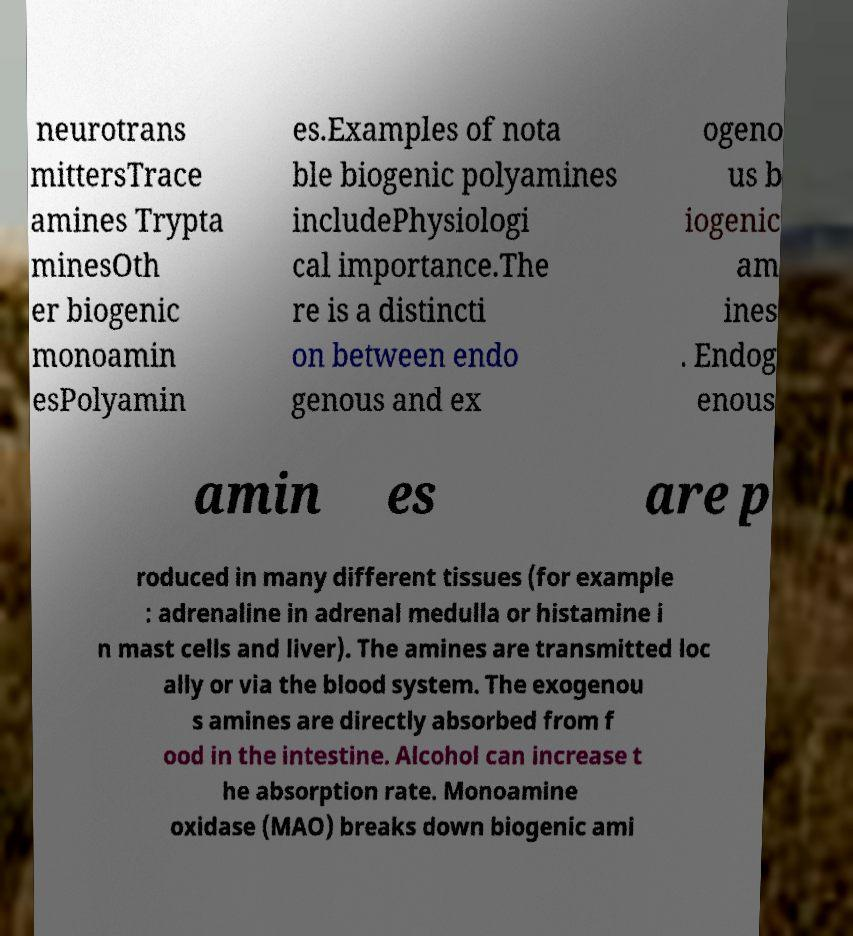I need the written content from this picture converted into text. Can you do that? neurotrans mittersTrace amines Trypta minesOth er biogenic monoamin esPolyamin es.Examples of nota ble biogenic polyamines includePhysiologi cal importance.The re is a distincti on between endo genous and ex ogeno us b iogenic am ines . Endog enous amin es are p roduced in many different tissues (for example : adrenaline in adrenal medulla or histamine i n mast cells and liver). The amines are transmitted loc ally or via the blood system. The exogenou s amines are directly absorbed from f ood in the intestine. Alcohol can increase t he absorption rate. Monoamine oxidase (MAO) breaks down biogenic ami 